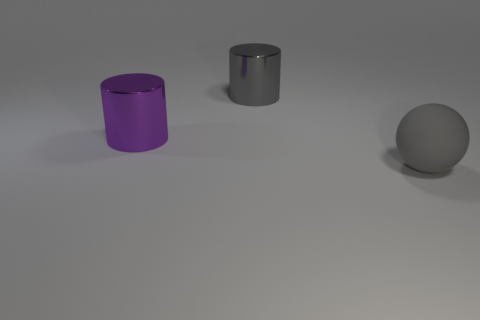Subtract all gray cylinders. How many cylinders are left? 1 Subtract 1 spheres. How many spheres are left? 0 Add 3 spheres. How many objects exist? 6 Subtract all balls. How many objects are left? 2 Subtract all green blocks. How many gray cylinders are left? 1 Add 3 big matte spheres. How many big matte spheres are left? 4 Add 1 purple metallic cylinders. How many purple metallic cylinders exist? 2 Subtract 0 yellow cylinders. How many objects are left? 3 Subtract all purple cylinders. Subtract all cyan balls. How many cylinders are left? 1 Subtract all big things. Subtract all red cubes. How many objects are left? 0 